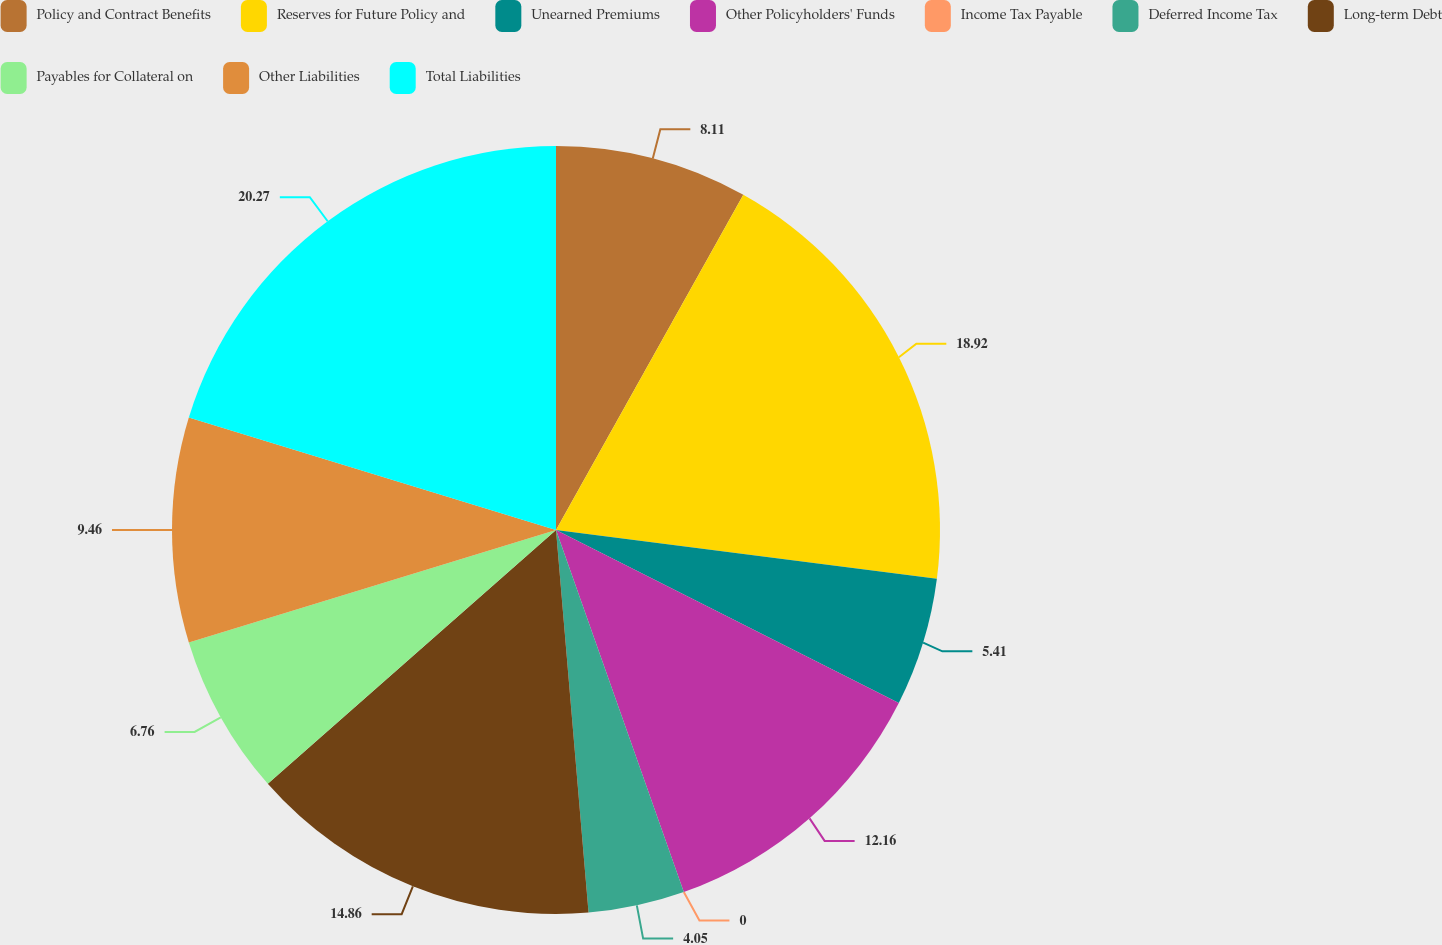<chart> <loc_0><loc_0><loc_500><loc_500><pie_chart><fcel>Policy and Contract Benefits<fcel>Reserves for Future Policy and<fcel>Unearned Premiums<fcel>Other Policyholders' Funds<fcel>Income Tax Payable<fcel>Deferred Income Tax<fcel>Long-term Debt<fcel>Payables for Collateral on<fcel>Other Liabilities<fcel>Total Liabilities<nl><fcel>8.11%<fcel>18.92%<fcel>5.41%<fcel>12.16%<fcel>0.0%<fcel>4.05%<fcel>14.86%<fcel>6.76%<fcel>9.46%<fcel>20.27%<nl></chart> 